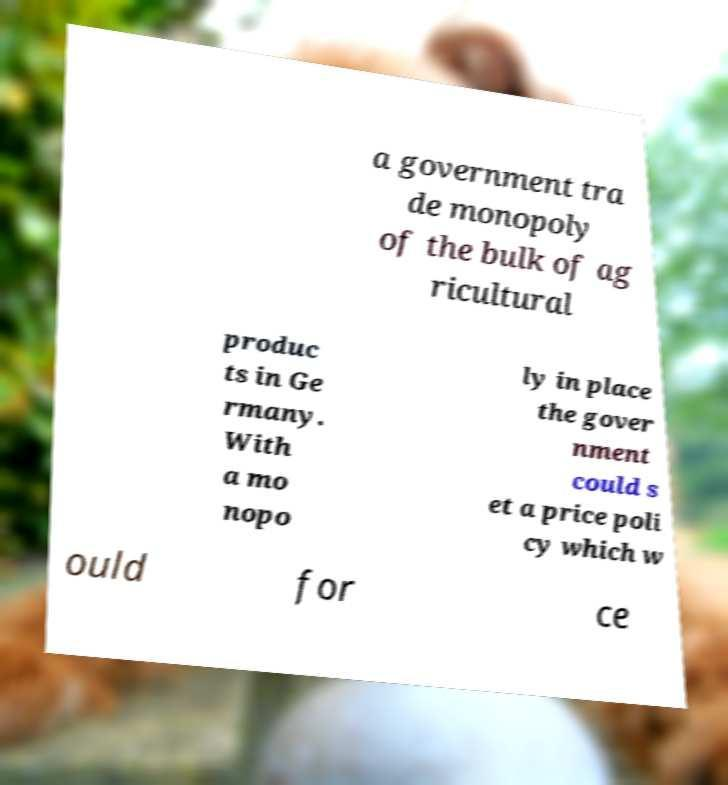Please read and relay the text visible in this image. What does it say? a government tra de monopoly of the bulk of ag ricultural produc ts in Ge rmany. With a mo nopo ly in place the gover nment could s et a price poli cy which w ould for ce 